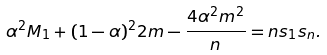<formula> <loc_0><loc_0><loc_500><loc_500>\alpha ^ { 2 } M _ { 1 } + ( 1 - \alpha ) ^ { 2 } 2 m - \frac { 4 \alpha ^ { 2 } m ^ { 2 } } { n } = n s _ { 1 } s _ { n } .</formula> 